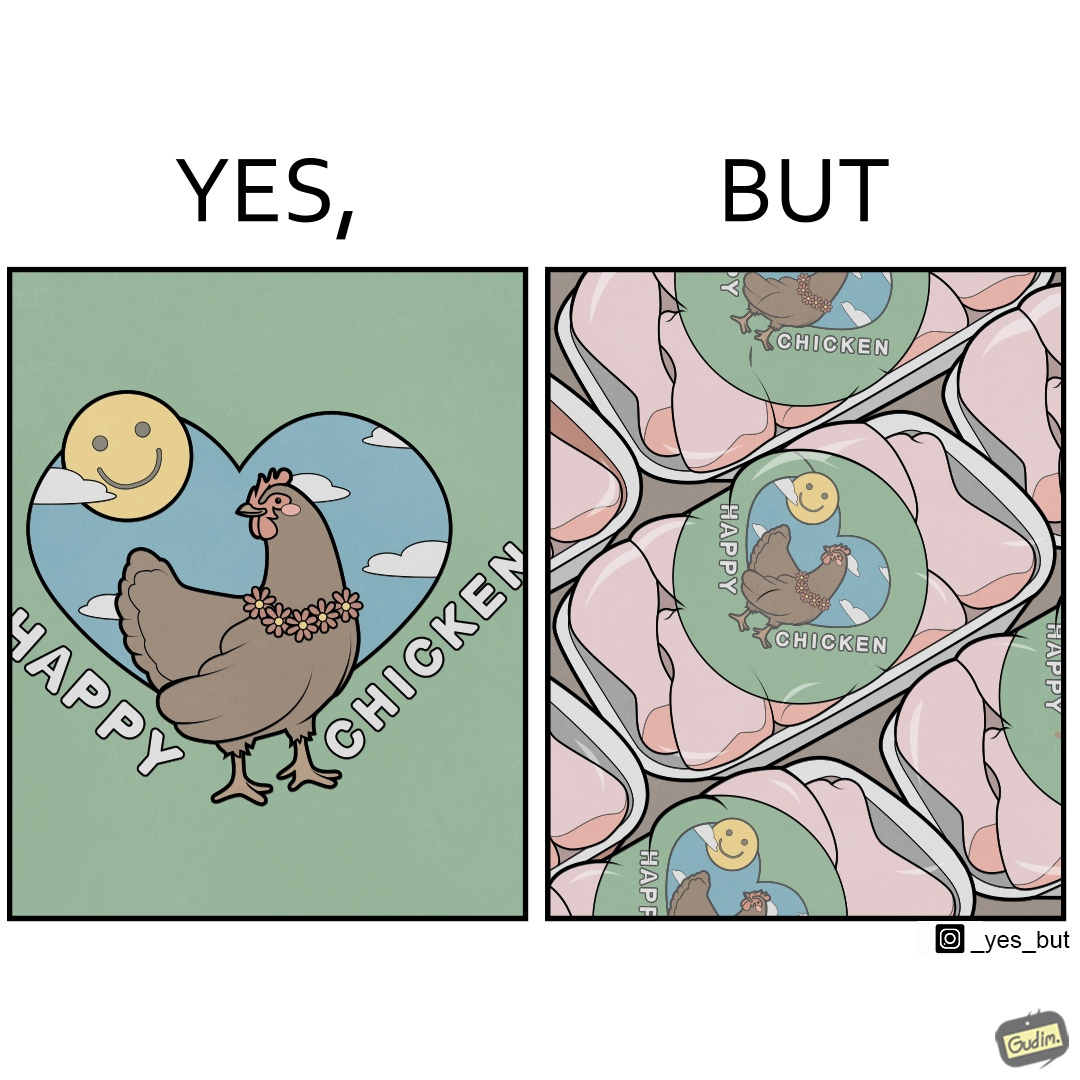Is there satirical content in this image? Yes, this image is satirical. 